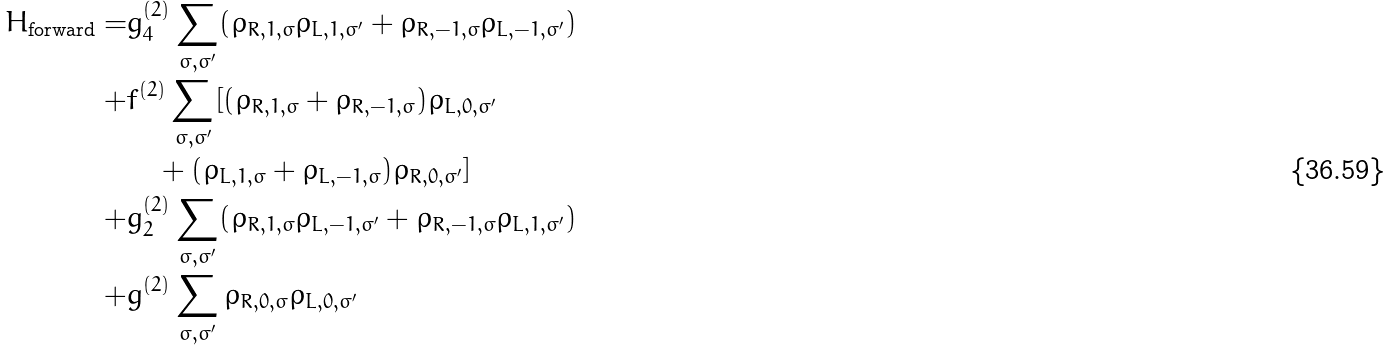Convert formula to latex. <formula><loc_0><loc_0><loc_500><loc_500>H _ { \text {forward} } = & g _ { 4 } ^ { ( 2 ) } \sum _ { \sigma , \sigma ^ { \prime } } ( \rho _ { R , 1 , \sigma } \rho _ { L , 1 , \sigma ^ { \prime } } + \rho _ { R , - 1 , \sigma } \rho _ { L , - 1 , \sigma ^ { \prime } } ) \\ + & f ^ { ( 2 ) } \sum _ { \sigma , \sigma ^ { \prime } } [ ( \rho _ { R , 1 , \sigma } + \rho _ { R , - 1 , \sigma } ) \rho _ { L , 0 , \sigma ^ { \prime } } \\ & \quad + ( \rho _ { L , 1 , \sigma } + \rho _ { L , - 1 , \sigma } ) \rho _ { R , 0 , \sigma ^ { \prime } } ] \\ + & g _ { 2 } ^ { ( 2 ) } \sum _ { \sigma , \sigma ^ { \prime } } ( \rho _ { R , 1 , \sigma } \rho _ { L , - 1 , \sigma ^ { \prime } } + \rho _ { R , - 1 , \sigma } \rho _ { L , 1 , \sigma ^ { \prime } } ) \\ + & g ^ { ( 2 ) } \sum _ { \sigma , \sigma ^ { \prime } } \rho _ { R , 0 , \sigma } \rho _ { L , 0 , \sigma ^ { \prime } }</formula> 